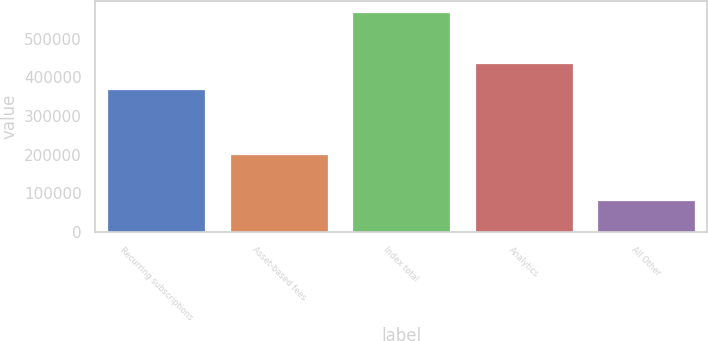Convert chart to OTSL. <chart><loc_0><loc_0><loc_500><loc_500><bar_chart><fcel>Recurring subscriptions<fcel>Asset-based fees<fcel>Index total<fcel>Analytics<fcel>All Other<nl><fcel>368855<fcel>201047<fcel>569902<fcel>436671<fcel>82677<nl></chart> 